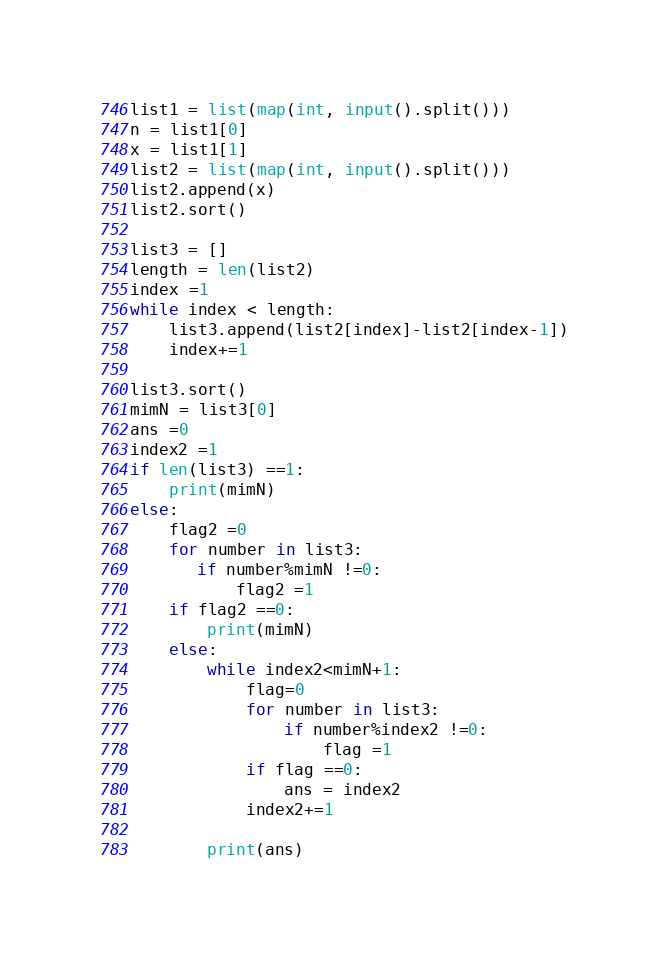Convert code to text. <code><loc_0><loc_0><loc_500><loc_500><_Python_>list1 = list(map(int, input().split()))
n = list1[0]
x = list1[1]
list2 = list(map(int, input().split()))
list2.append(x)
list2.sort()

list3 = []
length = len(list2)
index =1
while index < length:
    list3.append(list2[index]-list2[index-1])
    index+=1

list3.sort()
mimN = list3[0]
ans =0
index2 =1
if len(list3) ==1:
    print(mimN)
else:
    flag2 =0
    for number in list3:
       if number%mimN !=0:
           flag2 =1
    if flag2 ==0:
        print(mimN)
    else:
        while index2<mimN+1:
            flag=0
            for number in list3:
                if number%index2 !=0:
                    flag =1
            if flag ==0:
                ans = index2
            index2+=1
            
        print(ans)</code> 